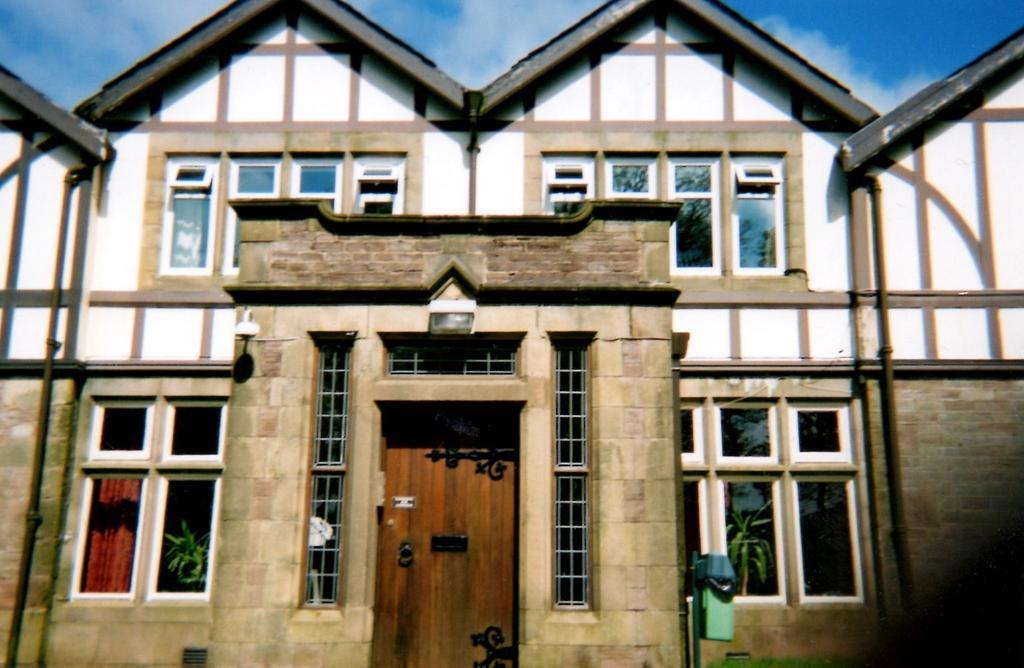Describe this image in one or two sentences. In this picture there is a building. At the bottom there is a door, beside that we can see the windows. At the top of the door there is a light, beside that there is a camera. At the top we can see sky and clouds. On the right and left side we can see the pipes. Through the window we can see the plants. 